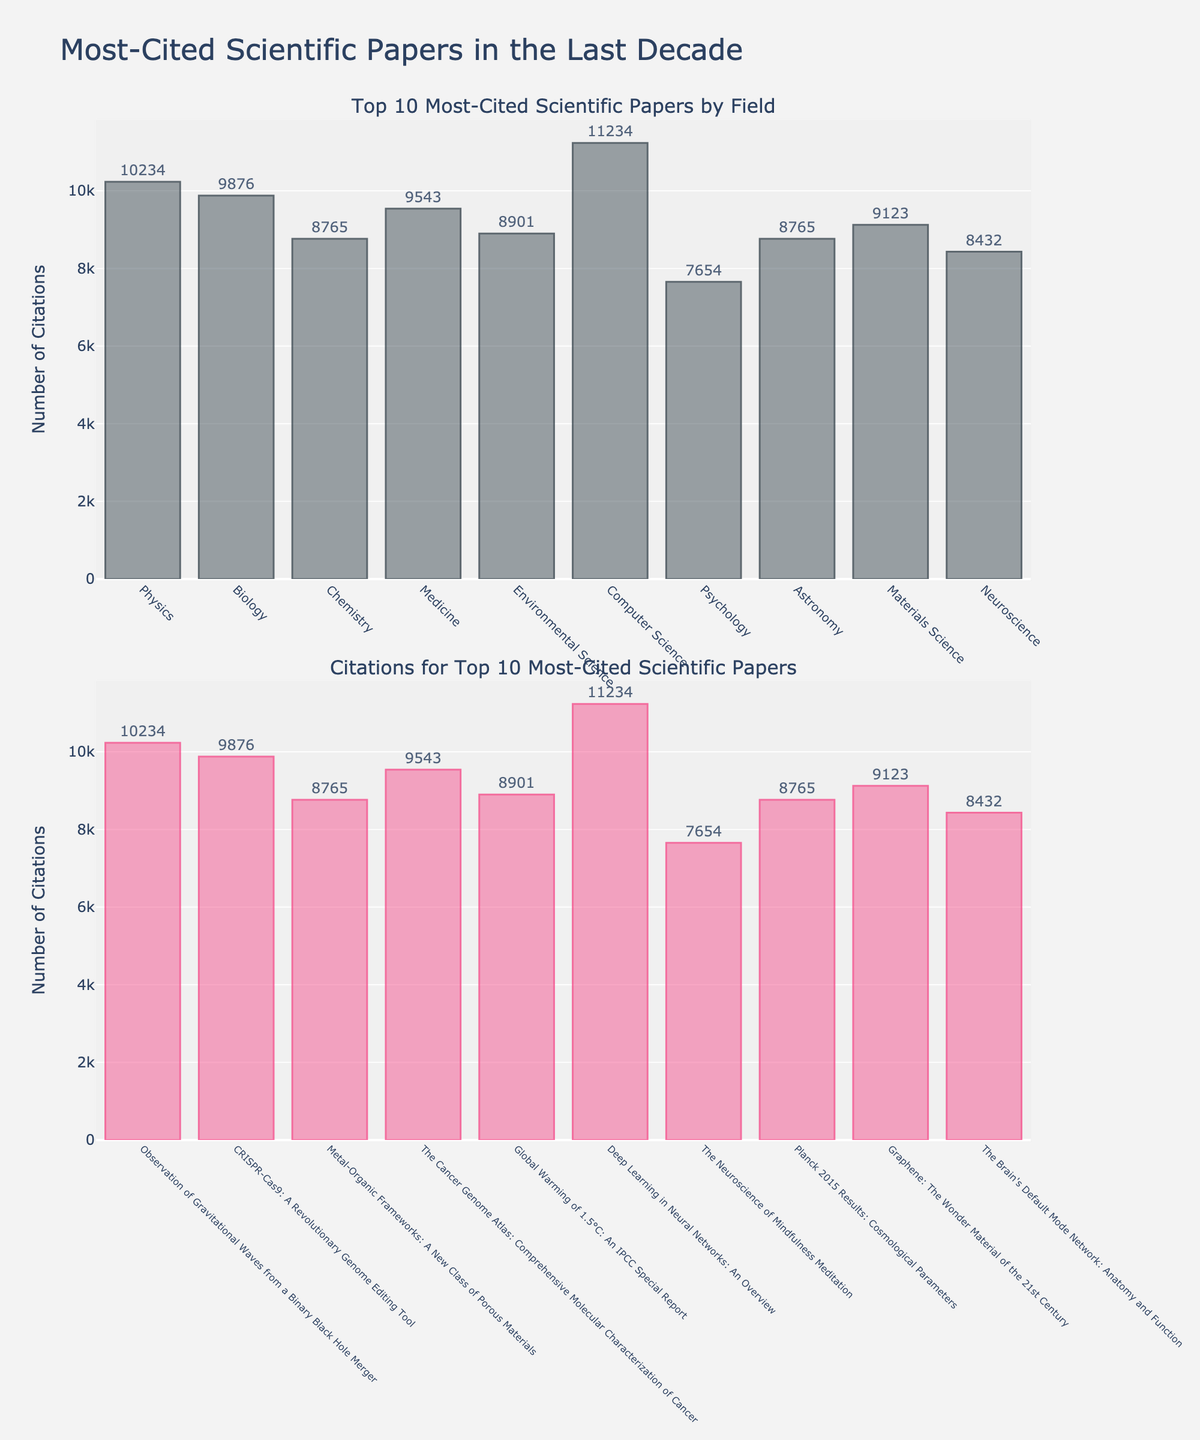What is the title of the figure? The title of the figure is usually located at the top and is meant to summarize what the visualization represents.
Answer: Revenue Breakdown by Room Type and Season Which room type generated the highest revenue in the Summer? Identify the bar chart corresponding to Summer, then find the room type with the tallest bar.
Answer: Executive Suite What is the revenue for Deluxe Room in Winter? Locate the Winter subplot, find the bar corresponding to Deluxe Room and read its height/value.
Answer: 18000 How much more revenue did the Suite generate in Spring compared to Winter? Find the values for Suite in both Spring and Winter and subtract the Winter value from the Spring value: 30000 - 25000.
Answer: 5000 Which season generated the least revenue for Standard Room? Compare the heights of the bars labeled Standard Room across all seasons and find the shortest one.
Answer: Winter What is the average revenue of all room types in Fall? Sum the revenues of all room types in Fall and divide by the number of room types (4): (18000 + 26000 + 35000 + 45000) / 4.
Answer: 31000 Does the revenue for Executive Suite in Spring exceed that of Suite in Summer? Compare the bar heights of Executive Suite in Spring and Suite in Summer to determine which is higher.
Answer: No Which room type showed the most consistent revenue across all seasons? Evaluate the heights of bars for each room type across seasons and identify the one with the least variation.
Answer: Standard Room What is the total revenue for Deluxe Room across all seasons? Sum the revenues for Deluxe Room in all seasons: 22000 + 35000 + 26000 + 18000.
Answer: 101000 How does the revenue for Standard Room in Fall compare to that in Spring? Compare the heights of the bars for Standard Room in Fall and Spring to see if Fall's revenue is higher or lower.
Answer: Higher in Fall 